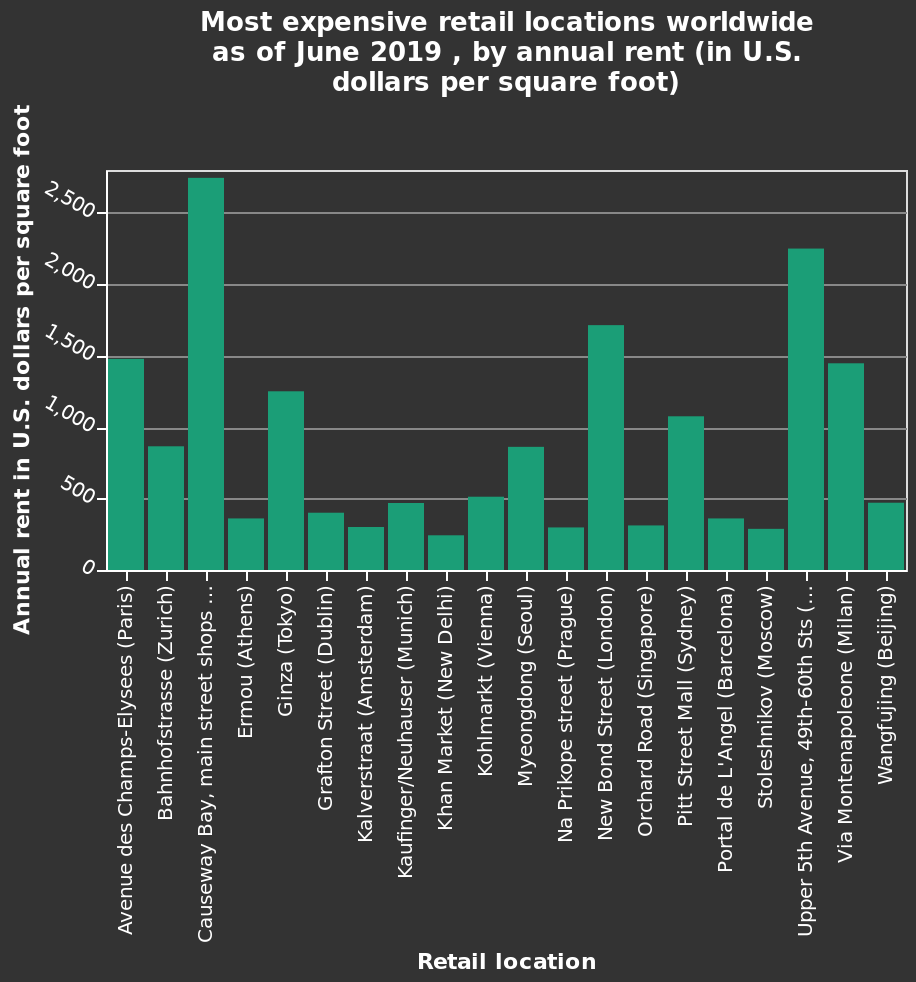<image>
What is shown on the x-axis of the bar chart?  The x-axis represents the retail locations. What is represented on the y-axis of the bar chart?  The y-axis represents the annual rent in U.S. dollars per square foot. 